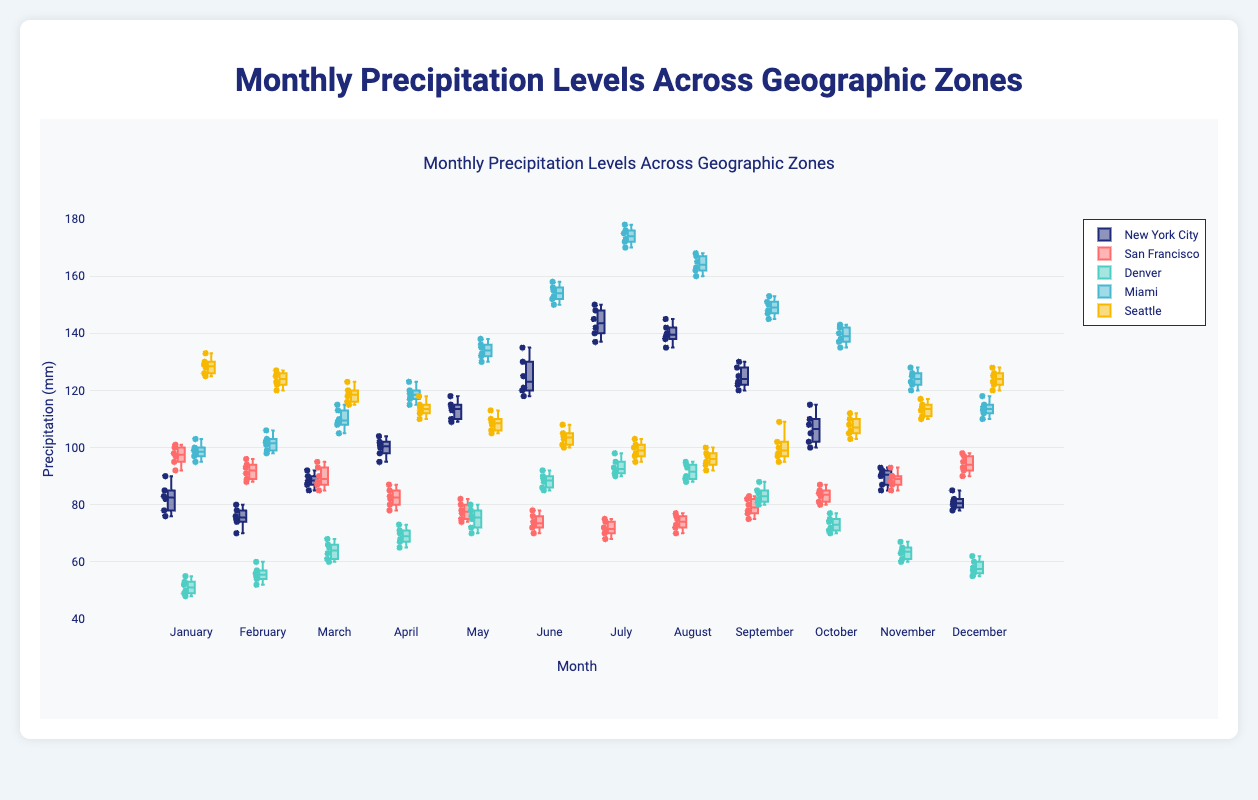What is the title of the plot? The title is displayed at the top of the plot and indicates the main topic being visualized. Here, it reads "Monthly Precipitation Levels Across Geographic Zones."
Answer: Monthly Precipitation Levels Across Geographic Zones Which city has the highest median precipitation level in July? In a box plot, the median is represented by the line inside the box. In July, Miami has the highest median, with the box's central line positioned higher than those of other cities.
Answer: Miami During which month does New York City have the smallest range of precipitation levels? The range of precipitation in a box plot is noted by the distance from the bottom to the top of the box. In December, New York City shows the smallest range, indicating the most consistent levels.
Answer: December Which city exhibits the most variability in precipitation levels in June? Variability in a box plot is suggested by the box's height and the length of the whiskers. Miami has the most variability in June, with a significantly taller box and longer whiskers compared to other cities.
Answer: Miami In which month does Seattle's precipitation level show an outlier? Outliers in a box plot are usually shown as individual points outside the whiskers. In September, Seattle has an outlier, seen clearly outside the main cluster of data points.
Answer: September In August, how does the precipitation level in Denver compare to New York City? By looking at the median lines inside the boxes for August, Denver's median precipitation level is lower than that of New York City.
Answer: Lower Which city and month combination sees the peak in precipitation levels across all data? Examining all the cities and months, the highest top whisker is in July for Miami, suggesting it has the peak precipitation level.
Answer: Miami in July How does the spread of precipitation levels in February compare between San Francisco and Seattle? The spread is indicated by the size of the box and the whiskers. In February, San Francisco shows a slightly narrower box and shorter whiskers compared to Seattle, indicating less variation in precipitation levels.
Answer: San Francisco has less spread than Seattle Is there any month where Denver's median precipitation exceeds New York City's median precipitation? By comparing median lines (central lines in each box) for all months, there is no month where Denver's median exceeds New York City's median.
Answer: No 